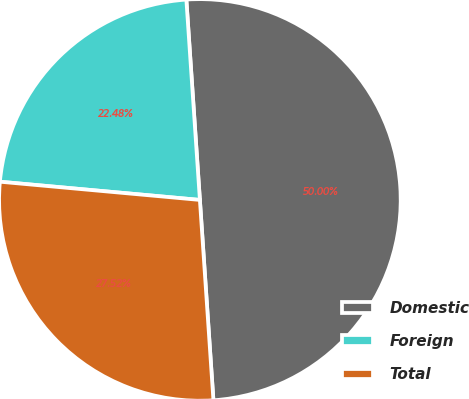Convert chart. <chart><loc_0><loc_0><loc_500><loc_500><pie_chart><fcel>Domestic<fcel>Foreign<fcel>Total<nl><fcel>50.0%<fcel>22.48%<fcel>27.52%<nl></chart> 